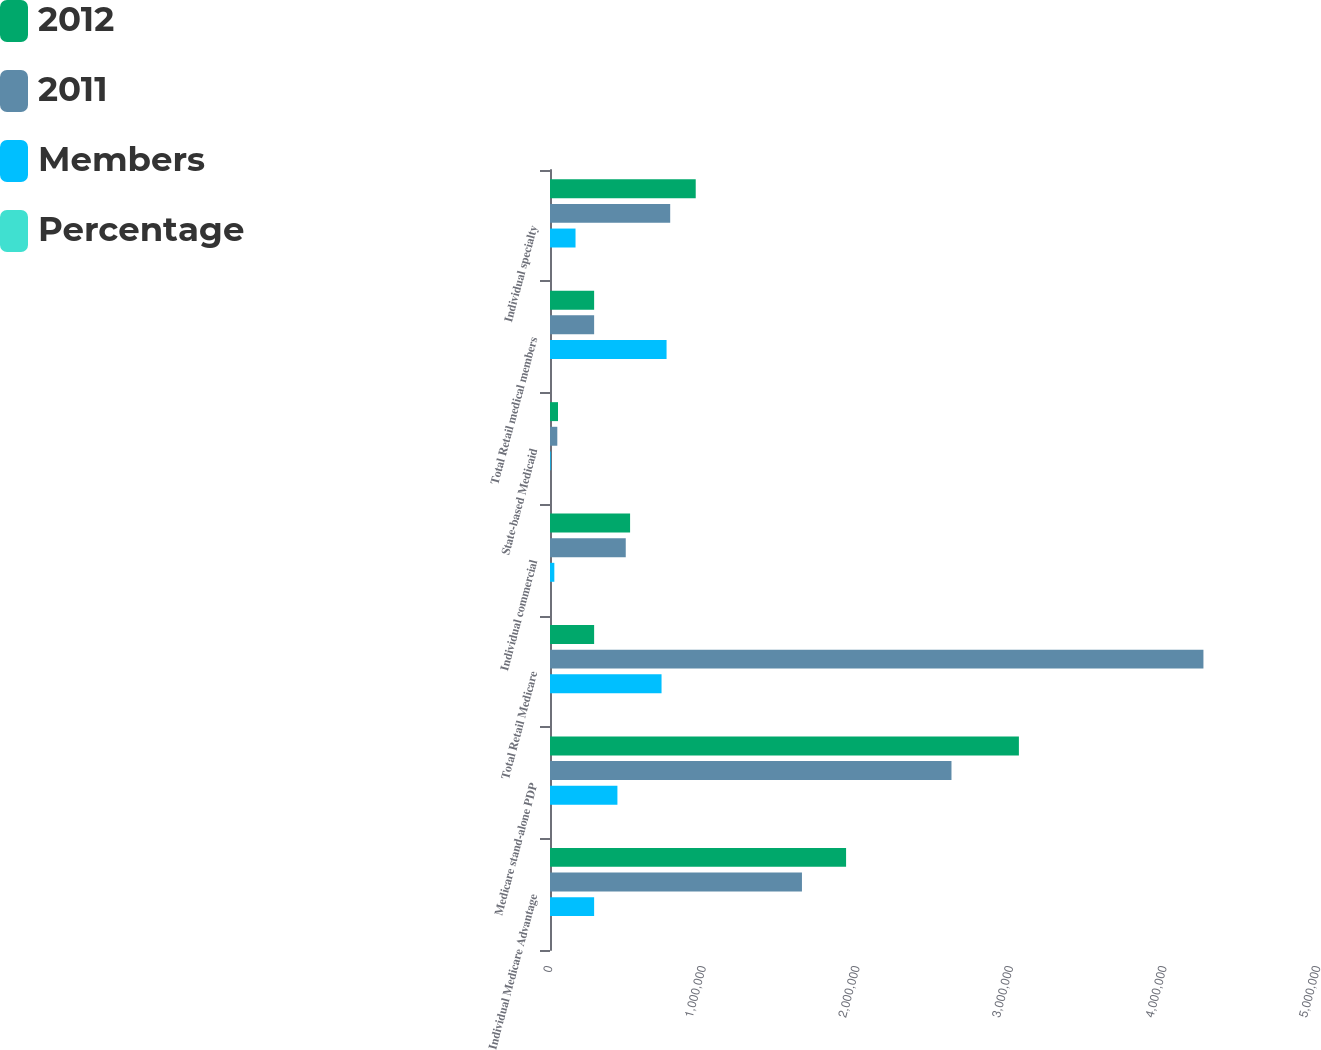<chart> <loc_0><loc_0><loc_500><loc_500><stacked_bar_chart><ecel><fcel>Individual Medicare Advantage<fcel>Medicare stand-alone PDP<fcel>Total Retail Medicare<fcel>Individual commercial<fcel>State-based Medicaid<fcel>Total Retail medical members<fcel>Individual specialty<nl><fcel>2012<fcel>1.9276e+06<fcel>3.0527e+06<fcel>287300<fcel>521400<fcel>52100<fcel>287300<fcel>948700<nl><fcel>2011<fcel>1.6403e+06<fcel>2.6138e+06<fcel>4.2541e+06<fcel>493200<fcel>47600<fcel>287300<fcel>782500<nl><fcel>Members<fcel>287300<fcel>438900<fcel>726200<fcel>28200<fcel>4500<fcel>758900<fcel>166200<nl><fcel>Percentage<fcel>17.5<fcel>16.8<fcel>17.1<fcel>5.7<fcel>9.5<fcel>15.8<fcel>21.2<nl></chart> 